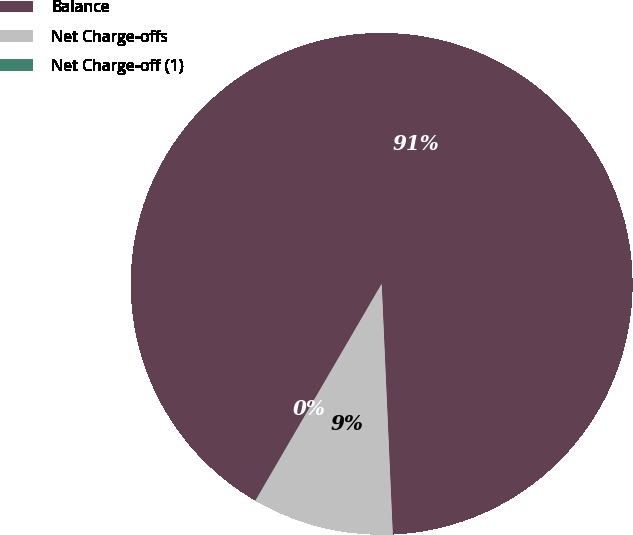Convert chart. <chart><loc_0><loc_0><loc_500><loc_500><pie_chart><fcel>Balance<fcel>Net Charge-offs<fcel>Net Charge-off (1)<nl><fcel>90.89%<fcel>9.1%<fcel>0.01%<nl></chart> 